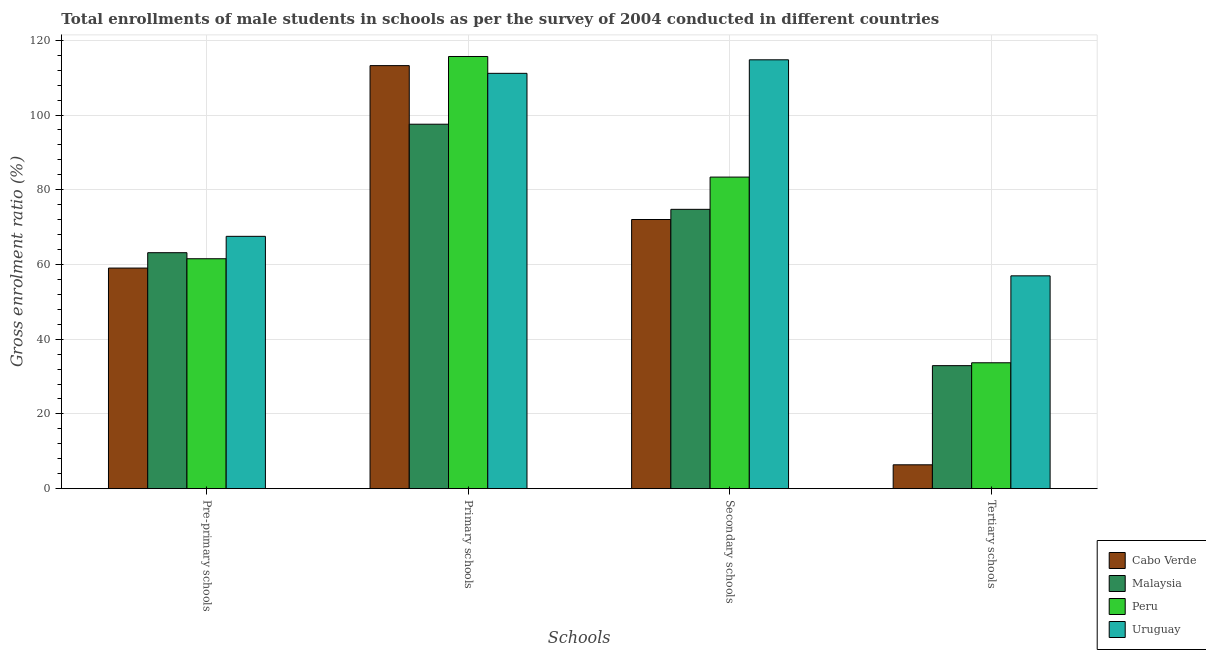How many different coloured bars are there?
Offer a very short reply. 4. Are the number of bars on each tick of the X-axis equal?
Offer a very short reply. Yes. What is the label of the 1st group of bars from the left?
Your answer should be compact. Pre-primary schools. What is the gross enrolment ratio(male) in secondary schools in Peru?
Offer a terse response. 83.39. Across all countries, what is the maximum gross enrolment ratio(male) in pre-primary schools?
Keep it short and to the point. 67.53. Across all countries, what is the minimum gross enrolment ratio(male) in secondary schools?
Ensure brevity in your answer.  72.04. In which country was the gross enrolment ratio(male) in pre-primary schools maximum?
Offer a very short reply. Uruguay. In which country was the gross enrolment ratio(male) in primary schools minimum?
Offer a terse response. Malaysia. What is the total gross enrolment ratio(male) in primary schools in the graph?
Provide a short and direct response. 437.58. What is the difference between the gross enrolment ratio(male) in secondary schools in Cabo Verde and that in Uruguay?
Ensure brevity in your answer.  -42.74. What is the difference between the gross enrolment ratio(male) in tertiary schools in Peru and the gross enrolment ratio(male) in primary schools in Uruguay?
Provide a succinct answer. -77.46. What is the average gross enrolment ratio(male) in primary schools per country?
Offer a very short reply. 109.4. What is the difference between the gross enrolment ratio(male) in primary schools and gross enrolment ratio(male) in tertiary schools in Malaysia?
Offer a very short reply. 64.61. What is the ratio of the gross enrolment ratio(male) in tertiary schools in Peru to that in Malaysia?
Provide a succinct answer. 1.02. Is the gross enrolment ratio(male) in tertiary schools in Peru less than that in Cabo Verde?
Your response must be concise. No. Is the difference between the gross enrolment ratio(male) in secondary schools in Malaysia and Peru greater than the difference between the gross enrolment ratio(male) in tertiary schools in Malaysia and Peru?
Provide a succinct answer. No. What is the difference between the highest and the second highest gross enrolment ratio(male) in pre-primary schools?
Offer a very short reply. 4.38. What is the difference between the highest and the lowest gross enrolment ratio(male) in tertiary schools?
Offer a terse response. 50.57. In how many countries, is the gross enrolment ratio(male) in tertiary schools greater than the average gross enrolment ratio(male) in tertiary schools taken over all countries?
Ensure brevity in your answer.  3. Is the sum of the gross enrolment ratio(male) in secondary schools in Cabo Verde and Peru greater than the maximum gross enrolment ratio(male) in primary schools across all countries?
Offer a very short reply. Yes. What does the 2nd bar from the left in Primary schools represents?
Keep it short and to the point. Malaysia. What does the 4th bar from the right in Tertiary schools represents?
Your answer should be compact. Cabo Verde. Is it the case that in every country, the sum of the gross enrolment ratio(male) in pre-primary schools and gross enrolment ratio(male) in primary schools is greater than the gross enrolment ratio(male) in secondary schools?
Provide a succinct answer. Yes. How many countries are there in the graph?
Your answer should be very brief. 4. Does the graph contain any zero values?
Your answer should be compact. No. Where does the legend appear in the graph?
Your response must be concise. Bottom right. How are the legend labels stacked?
Ensure brevity in your answer.  Vertical. What is the title of the graph?
Ensure brevity in your answer.  Total enrollments of male students in schools as per the survey of 2004 conducted in different countries. Does "New Zealand" appear as one of the legend labels in the graph?
Ensure brevity in your answer.  No. What is the label or title of the X-axis?
Provide a succinct answer. Schools. What is the label or title of the Y-axis?
Keep it short and to the point. Gross enrolment ratio (%). What is the Gross enrolment ratio (%) in Cabo Verde in Pre-primary schools?
Provide a short and direct response. 59.04. What is the Gross enrolment ratio (%) of Malaysia in Pre-primary schools?
Give a very brief answer. 63.15. What is the Gross enrolment ratio (%) of Peru in Pre-primary schools?
Make the answer very short. 61.54. What is the Gross enrolment ratio (%) in Uruguay in Pre-primary schools?
Ensure brevity in your answer.  67.53. What is the Gross enrolment ratio (%) in Cabo Verde in Primary schools?
Provide a short and direct response. 113.22. What is the Gross enrolment ratio (%) in Malaysia in Primary schools?
Ensure brevity in your answer.  97.54. What is the Gross enrolment ratio (%) of Peru in Primary schools?
Offer a terse response. 115.66. What is the Gross enrolment ratio (%) in Uruguay in Primary schools?
Ensure brevity in your answer.  111.16. What is the Gross enrolment ratio (%) of Cabo Verde in Secondary schools?
Provide a succinct answer. 72.04. What is the Gross enrolment ratio (%) of Malaysia in Secondary schools?
Ensure brevity in your answer.  74.76. What is the Gross enrolment ratio (%) of Peru in Secondary schools?
Keep it short and to the point. 83.39. What is the Gross enrolment ratio (%) in Uruguay in Secondary schools?
Give a very brief answer. 114.78. What is the Gross enrolment ratio (%) of Cabo Verde in Tertiary schools?
Provide a short and direct response. 6.39. What is the Gross enrolment ratio (%) of Malaysia in Tertiary schools?
Offer a very short reply. 32.92. What is the Gross enrolment ratio (%) in Peru in Tertiary schools?
Offer a terse response. 33.69. What is the Gross enrolment ratio (%) of Uruguay in Tertiary schools?
Provide a short and direct response. 56.96. Across all Schools, what is the maximum Gross enrolment ratio (%) of Cabo Verde?
Offer a very short reply. 113.22. Across all Schools, what is the maximum Gross enrolment ratio (%) in Malaysia?
Ensure brevity in your answer.  97.54. Across all Schools, what is the maximum Gross enrolment ratio (%) in Peru?
Ensure brevity in your answer.  115.66. Across all Schools, what is the maximum Gross enrolment ratio (%) of Uruguay?
Your answer should be very brief. 114.78. Across all Schools, what is the minimum Gross enrolment ratio (%) in Cabo Verde?
Ensure brevity in your answer.  6.39. Across all Schools, what is the minimum Gross enrolment ratio (%) of Malaysia?
Keep it short and to the point. 32.92. Across all Schools, what is the minimum Gross enrolment ratio (%) of Peru?
Provide a succinct answer. 33.69. Across all Schools, what is the minimum Gross enrolment ratio (%) in Uruguay?
Keep it short and to the point. 56.96. What is the total Gross enrolment ratio (%) in Cabo Verde in the graph?
Your response must be concise. 250.69. What is the total Gross enrolment ratio (%) in Malaysia in the graph?
Offer a terse response. 268.37. What is the total Gross enrolment ratio (%) in Peru in the graph?
Provide a succinct answer. 294.28. What is the total Gross enrolment ratio (%) in Uruguay in the graph?
Provide a short and direct response. 350.43. What is the difference between the Gross enrolment ratio (%) in Cabo Verde in Pre-primary schools and that in Primary schools?
Offer a very short reply. -54.18. What is the difference between the Gross enrolment ratio (%) in Malaysia in Pre-primary schools and that in Primary schools?
Keep it short and to the point. -34.39. What is the difference between the Gross enrolment ratio (%) in Peru in Pre-primary schools and that in Primary schools?
Provide a succinct answer. -54.13. What is the difference between the Gross enrolment ratio (%) of Uruguay in Pre-primary schools and that in Primary schools?
Give a very brief answer. -43.62. What is the difference between the Gross enrolment ratio (%) in Cabo Verde in Pre-primary schools and that in Secondary schools?
Provide a succinct answer. -13. What is the difference between the Gross enrolment ratio (%) of Malaysia in Pre-primary schools and that in Secondary schools?
Provide a succinct answer. -11.6. What is the difference between the Gross enrolment ratio (%) in Peru in Pre-primary schools and that in Secondary schools?
Your answer should be very brief. -21.85. What is the difference between the Gross enrolment ratio (%) in Uruguay in Pre-primary schools and that in Secondary schools?
Provide a succinct answer. -47.24. What is the difference between the Gross enrolment ratio (%) in Cabo Verde in Pre-primary schools and that in Tertiary schools?
Provide a succinct answer. 52.65. What is the difference between the Gross enrolment ratio (%) of Malaysia in Pre-primary schools and that in Tertiary schools?
Make the answer very short. 30.23. What is the difference between the Gross enrolment ratio (%) of Peru in Pre-primary schools and that in Tertiary schools?
Give a very brief answer. 27.84. What is the difference between the Gross enrolment ratio (%) in Uruguay in Pre-primary schools and that in Tertiary schools?
Provide a short and direct response. 10.57. What is the difference between the Gross enrolment ratio (%) of Cabo Verde in Primary schools and that in Secondary schools?
Make the answer very short. 41.19. What is the difference between the Gross enrolment ratio (%) in Malaysia in Primary schools and that in Secondary schools?
Offer a very short reply. 22.78. What is the difference between the Gross enrolment ratio (%) in Peru in Primary schools and that in Secondary schools?
Your answer should be very brief. 32.28. What is the difference between the Gross enrolment ratio (%) in Uruguay in Primary schools and that in Secondary schools?
Your response must be concise. -3.62. What is the difference between the Gross enrolment ratio (%) in Cabo Verde in Primary schools and that in Tertiary schools?
Your answer should be compact. 106.83. What is the difference between the Gross enrolment ratio (%) in Malaysia in Primary schools and that in Tertiary schools?
Provide a short and direct response. 64.61. What is the difference between the Gross enrolment ratio (%) of Peru in Primary schools and that in Tertiary schools?
Your response must be concise. 81.97. What is the difference between the Gross enrolment ratio (%) of Uruguay in Primary schools and that in Tertiary schools?
Offer a very short reply. 54.2. What is the difference between the Gross enrolment ratio (%) of Cabo Verde in Secondary schools and that in Tertiary schools?
Ensure brevity in your answer.  65.65. What is the difference between the Gross enrolment ratio (%) in Malaysia in Secondary schools and that in Tertiary schools?
Make the answer very short. 41.83. What is the difference between the Gross enrolment ratio (%) of Peru in Secondary schools and that in Tertiary schools?
Give a very brief answer. 49.69. What is the difference between the Gross enrolment ratio (%) in Uruguay in Secondary schools and that in Tertiary schools?
Keep it short and to the point. 57.82. What is the difference between the Gross enrolment ratio (%) of Cabo Verde in Pre-primary schools and the Gross enrolment ratio (%) of Malaysia in Primary schools?
Your answer should be compact. -38.5. What is the difference between the Gross enrolment ratio (%) of Cabo Verde in Pre-primary schools and the Gross enrolment ratio (%) of Peru in Primary schools?
Offer a very short reply. -56.62. What is the difference between the Gross enrolment ratio (%) of Cabo Verde in Pre-primary schools and the Gross enrolment ratio (%) of Uruguay in Primary schools?
Your response must be concise. -52.12. What is the difference between the Gross enrolment ratio (%) of Malaysia in Pre-primary schools and the Gross enrolment ratio (%) of Peru in Primary schools?
Your response must be concise. -52.51. What is the difference between the Gross enrolment ratio (%) in Malaysia in Pre-primary schools and the Gross enrolment ratio (%) in Uruguay in Primary schools?
Make the answer very short. -48. What is the difference between the Gross enrolment ratio (%) of Peru in Pre-primary schools and the Gross enrolment ratio (%) of Uruguay in Primary schools?
Keep it short and to the point. -49.62. What is the difference between the Gross enrolment ratio (%) in Cabo Verde in Pre-primary schools and the Gross enrolment ratio (%) in Malaysia in Secondary schools?
Give a very brief answer. -15.72. What is the difference between the Gross enrolment ratio (%) of Cabo Verde in Pre-primary schools and the Gross enrolment ratio (%) of Peru in Secondary schools?
Your answer should be very brief. -24.35. What is the difference between the Gross enrolment ratio (%) in Cabo Verde in Pre-primary schools and the Gross enrolment ratio (%) in Uruguay in Secondary schools?
Your answer should be very brief. -55.74. What is the difference between the Gross enrolment ratio (%) of Malaysia in Pre-primary schools and the Gross enrolment ratio (%) of Peru in Secondary schools?
Your response must be concise. -20.23. What is the difference between the Gross enrolment ratio (%) in Malaysia in Pre-primary schools and the Gross enrolment ratio (%) in Uruguay in Secondary schools?
Your answer should be very brief. -51.63. What is the difference between the Gross enrolment ratio (%) of Peru in Pre-primary schools and the Gross enrolment ratio (%) of Uruguay in Secondary schools?
Your answer should be very brief. -53.24. What is the difference between the Gross enrolment ratio (%) of Cabo Verde in Pre-primary schools and the Gross enrolment ratio (%) of Malaysia in Tertiary schools?
Provide a short and direct response. 26.12. What is the difference between the Gross enrolment ratio (%) of Cabo Verde in Pre-primary schools and the Gross enrolment ratio (%) of Peru in Tertiary schools?
Give a very brief answer. 25.35. What is the difference between the Gross enrolment ratio (%) of Cabo Verde in Pre-primary schools and the Gross enrolment ratio (%) of Uruguay in Tertiary schools?
Provide a short and direct response. 2.08. What is the difference between the Gross enrolment ratio (%) in Malaysia in Pre-primary schools and the Gross enrolment ratio (%) in Peru in Tertiary schools?
Your answer should be compact. 29.46. What is the difference between the Gross enrolment ratio (%) in Malaysia in Pre-primary schools and the Gross enrolment ratio (%) in Uruguay in Tertiary schools?
Provide a succinct answer. 6.19. What is the difference between the Gross enrolment ratio (%) in Peru in Pre-primary schools and the Gross enrolment ratio (%) in Uruguay in Tertiary schools?
Give a very brief answer. 4.58. What is the difference between the Gross enrolment ratio (%) in Cabo Verde in Primary schools and the Gross enrolment ratio (%) in Malaysia in Secondary schools?
Offer a very short reply. 38.47. What is the difference between the Gross enrolment ratio (%) in Cabo Verde in Primary schools and the Gross enrolment ratio (%) in Peru in Secondary schools?
Provide a succinct answer. 29.83. What is the difference between the Gross enrolment ratio (%) of Cabo Verde in Primary schools and the Gross enrolment ratio (%) of Uruguay in Secondary schools?
Offer a terse response. -1.56. What is the difference between the Gross enrolment ratio (%) in Malaysia in Primary schools and the Gross enrolment ratio (%) in Peru in Secondary schools?
Your answer should be very brief. 14.15. What is the difference between the Gross enrolment ratio (%) of Malaysia in Primary schools and the Gross enrolment ratio (%) of Uruguay in Secondary schools?
Provide a succinct answer. -17.24. What is the difference between the Gross enrolment ratio (%) in Peru in Primary schools and the Gross enrolment ratio (%) in Uruguay in Secondary schools?
Provide a short and direct response. 0.89. What is the difference between the Gross enrolment ratio (%) of Cabo Verde in Primary schools and the Gross enrolment ratio (%) of Malaysia in Tertiary schools?
Provide a succinct answer. 80.3. What is the difference between the Gross enrolment ratio (%) in Cabo Verde in Primary schools and the Gross enrolment ratio (%) in Peru in Tertiary schools?
Your response must be concise. 79.53. What is the difference between the Gross enrolment ratio (%) of Cabo Verde in Primary schools and the Gross enrolment ratio (%) of Uruguay in Tertiary schools?
Make the answer very short. 56.26. What is the difference between the Gross enrolment ratio (%) of Malaysia in Primary schools and the Gross enrolment ratio (%) of Peru in Tertiary schools?
Your answer should be compact. 63.85. What is the difference between the Gross enrolment ratio (%) in Malaysia in Primary schools and the Gross enrolment ratio (%) in Uruguay in Tertiary schools?
Your answer should be very brief. 40.58. What is the difference between the Gross enrolment ratio (%) in Peru in Primary schools and the Gross enrolment ratio (%) in Uruguay in Tertiary schools?
Provide a succinct answer. 58.7. What is the difference between the Gross enrolment ratio (%) in Cabo Verde in Secondary schools and the Gross enrolment ratio (%) in Malaysia in Tertiary schools?
Your answer should be very brief. 39.11. What is the difference between the Gross enrolment ratio (%) of Cabo Verde in Secondary schools and the Gross enrolment ratio (%) of Peru in Tertiary schools?
Provide a short and direct response. 38.34. What is the difference between the Gross enrolment ratio (%) in Cabo Verde in Secondary schools and the Gross enrolment ratio (%) in Uruguay in Tertiary schools?
Keep it short and to the point. 15.07. What is the difference between the Gross enrolment ratio (%) in Malaysia in Secondary schools and the Gross enrolment ratio (%) in Peru in Tertiary schools?
Give a very brief answer. 41.06. What is the difference between the Gross enrolment ratio (%) of Malaysia in Secondary schools and the Gross enrolment ratio (%) of Uruguay in Tertiary schools?
Make the answer very short. 17.8. What is the difference between the Gross enrolment ratio (%) in Peru in Secondary schools and the Gross enrolment ratio (%) in Uruguay in Tertiary schools?
Make the answer very short. 26.43. What is the average Gross enrolment ratio (%) in Cabo Verde per Schools?
Provide a short and direct response. 62.67. What is the average Gross enrolment ratio (%) of Malaysia per Schools?
Your answer should be compact. 67.09. What is the average Gross enrolment ratio (%) of Peru per Schools?
Offer a very short reply. 73.57. What is the average Gross enrolment ratio (%) of Uruguay per Schools?
Give a very brief answer. 87.61. What is the difference between the Gross enrolment ratio (%) of Cabo Verde and Gross enrolment ratio (%) of Malaysia in Pre-primary schools?
Offer a terse response. -4.11. What is the difference between the Gross enrolment ratio (%) of Cabo Verde and Gross enrolment ratio (%) of Peru in Pre-primary schools?
Your answer should be compact. -2.5. What is the difference between the Gross enrolment ratio (%) in Cabo Verde and Gross enrolment ratio (%) in Uruguay in Pre-primary schools?
Your answer should be very brief. -8.49. What is the difference between the Gross enrolment ratio (%) in Malaysia and Gross enrolment ratio (%) in Peru in Pre-primary schools?
Make the answer very short. 1.62. What is the difference between the Gross enrolment ratio (%) of Malaysia and Gross enrolment ratio (%) of Uruguay in Pre-primary schools?
Ensure brevity in your answer.  -4.38. What is the difference between the Gross enrolment ratio (%) of Peru and Gross enrolment ratio (%) of Uruguay in Pre-primary schools?
Make the answer very short. -6. What is the difference between the Gross enrolment ratio (%) of Cabo Verde and Gross enrolment ratio (%) of Malaysia in Primary schools?
Offer a very short reply. 15.68. What is the difference between the Gross enrolment ratio (%) of Cabo Verde and Gross enrolment ratio (%) of Peru in Primary schools?
Provide a succinct answer. -2.44. What is the difference between the Gross enrolment ratio (%) of Cabo Verde and Gross enrolment ratio (%) of Uruguay in Primary schools?
Offer a very short reply. 2.07. What is the difference between the Gross enrolment ratio (%) in Malaysia and Gross enrolment ratio (%) in Peru in Primary schools?
Your answer should be compact. -18.13. What is the difference between the Gross enrolment ratio (%) in Malaysia and Gross enrolment ratio (%) in Uruguay in Primary schools?
Provide a succinct answer. -13.62. What is the difference between the Gross enrolment ratio (%) of Peru and Gross enrolment ratio (%) of Uruguay in Primary schools?
Provide a short and direct response. 4.51. What is the difference between the Gross enrolment ratio (%) of Cabo Verde and Gross enrolment ratio (%) of Malaysia in Secondary schools?
Make the answer very short. -2.72. What is the difference between the Gross enrolment ratio (%) in Cabo Verde and Gross enrolment ratio (%) in Peru in Secondary schools?
Your response must be concise. -11.35. What is the difference between the Gross enrolment ratio (%) in Cabo Verde and Gross enrolment ratio (%) in Uruguay in Secondary schools?
Your response must be concise. -42.74. What is the difference between the Gross enrolment ratio (%) in Malaysia and Gross enrolment ratio (%) in Peru in Secondary schools?
Ensure brevity in your answer.  -8.63. What is the difference between the Gross enrolment ratio (%) in Malaysia and Gross enrolment ratio (%) in Uruguay in Secondary schools?
Ensure brevity in your answer.  -40.02. What is the difference between the Gross enrolment ratio (%) in Peru and Gross enrolment ratio (%) in Uruguay in Secondary schools?
Ensure brevity in your answer.  -31.39. What is the difference between the Gross enrolment ratio (%) of Cabo Verde and Gross enrolment ratio (%) of Malaysia in Tertiary schools?
Your response must be concise. -26.54. What is the difference between the Gross enrolment ratio (%) of Cabo Verde and Gross enrolment ratio (%) of Peru in Tertiary schools?
Keep it short and to the point. -27.31. What is the difference between the Gross enrolment ratio (%) in Cabo Verde and Gross enrolment ratio (%) in Uruguay in Tertiary schools?
Your answer should be very brief. -50.57. What is the difference between the Gross enrolment ratio (%) in Malaysia and Gross enrolment ratio (%) in Peru in Tertiary schools?
Keep it short and to the point. -0.77. What is the difference between the Gross enrolment ratio (%) in Malaysia and Gross enrolment ratio (%) in Uruguay in Tertiary schools?
Provide a succinct answer. -24.04. What is the difference between the Gross enrolment ratio (%) in Peru and Gross enrolment ratio (%) in Uruguay in Tertiary schools?
Provide a succinct answer. -23.27. What is the ratio of the Gross enrolment ratio (%) of Cabo Verde in Pre-primary schools to that in Primary schools?
Your answer should be very brief. 0.52. What is the ratio of the Gross enrolment ratio (%) in Malaysia in Pre-primary schools to that in Primary schools?
Offer a terse response. 0.65. What is the ratio of the Gross enrolment ratio (%) of Peru in Pre-primary schools to that in Primary schools?
Provide a short and direct response. 0.53. What is the ratio of the Gross enrolment ratio (%) in Uruguay in Pre-primary schools to that in Primary schools?
Offer a terse response. 0.61. What is the ratio of the Gross enrolment ratio (%) in Cabo Verde in Pre-primary schools to that in Secondary schools?
Keep it short and to the point. 0.82. What is the ratio of the Gross enrolment ratio (%) in Malaysia in Pre-primary schools to that in Secondary schools?
Provide a succinct answer. 0.84. What is the ratio of the Gross enrolment ratio (%) of Peru in Pre-primary schools to that in Secondary schools?
Provide a short and direct response. 0.74. What is the ratio of the Gross enrolment ratio (%) in Uruguay in Pre-primary schools to that in Secondary schools?
Your answer should be compact. 0.59. What is the ratio of the Gross enrolment ratio (%) of Cabo Verde in Pre-primary schools to that in Tertiary schools?
Offer a terse response. 9.24. What is the ratio of the Gross enrolment ratio (%) of Malaysia in Pre-primary schools to that in Tertiary schools?
Your response must be concise. 1.92. What is the ratio of the Gross enrolment ratio (%) in Peru in Pre-primary schools to that in Tertiary schools?
Your answer should be very brief. 1.83. What is the ratio of the Gross enrolment ratio (%) in Uruguay in Pre-primary schools to that in Tertiary schools?
Your response must be concise. 1.19. What is the ratio of the Gross enrolment ratio (%) of Cabo Verde in Primary schools to that in Secondary schools?
Make the answer very short. 1.57. What is the ratio of the Gross enrolment ratio (%) of Malaysia in Primary schools to that in Secondary schools?
Give a very brief answer. 1.3. What is the ratio of the Gross enrolment ratio (%) of Peru in Primary schools to that in Secondary schools?
Your answer should be compact. 1.39. What is the ratio of the Gross enrolment ratio (%) of Uruguay in Primary schools to that in Secondary schools?
Your answer should be compact. 0.97. What is the ratio of the Gross enrolment ratio (%) in Cabo Verde in Primary schools to that in Tertiary schools?
Provide a short and direct response. 17.72. What is the ratio of the Gross enrolment ratio (%) of Malaysia in Primary schools to that in Tertiary schools?
Make the answer very short. 2.96. What is the ratio of the Gross enrolment ratio (%) in Peru in Primary schools to that in Tertiary schools?
Offer a very short reply. 3.43. What is the ratio of the Gross enrolment ratio (%) in Uruguay in Primary schools to that in Tertiary schools?
Your answer should be very brief. 1.95. What is the ratio of the Gross enrolment ratio (%) in Cabo Verde in Secondary schools to that in Tertiary schools?
Offer a very short reply. 11.28. What is the ratio of the Gross enrolment ratio (%) in Malaysia in Secondary schools to that in Tertiary schools?
Offer a very short reply. 2.27. What is the ratio of the Gross enrolment ratio (%) of Peru in Secondary schools to that in Tertiary schools?
Give a very brief answer. 2.47. What is the ratio of the Gross enrolment ratio (%) of Uruguay in Secondary schools to that in Tertiary schools?
Your answer should be very brief. 2.02. What is the difference between the highest and the second highest Gross enrolment ratio (%) of Cabo Verde?
Provide a succinct answer. 41.19. What is the difference between the highest and the second highest Gross enrolment ratio (%) in Malaysia?
Your answer should be compact. 22.78. What is the difference between the highest and the second highest Gross enrolment ratio (%) in Peru?
Provide a short and direct response. 32.28. What is the difference between the highest and the second highest Gross enrolment ratio (%) of Uruguay?
Offer a very short reply. 3.62. What is the difference between the highest and the lowest Gross enrolment ratio (%) in Cabo Verde?
Give a very brief answer. 106.83. What is the difference between the highest and the lowest Gross enrolment ratio (%) in Malaysia?
Offer a terse response. 64.61. What is the difference between the highest and the lowest Gross enrolment ratio (%) of Peru?
Offer a very short reply. 81.97. What is the difference between the highest and the lowest Gross enrolment ratio (%) in Uruguay?
Your answer should be compact. 57.82. 